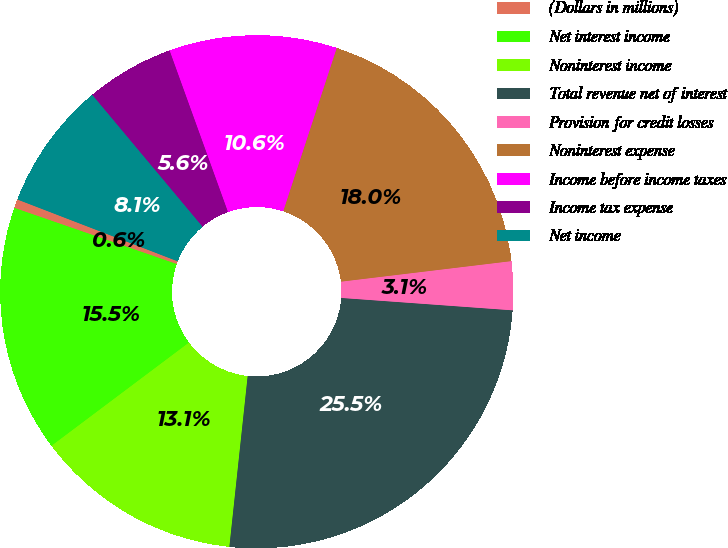Convert chart to OTSL. <chart><loc_0><loc_0><loc_500><loc_500><pie_chart><fcel>(Dollars in millions)<fcel>Net interest income<fcel>Noninterest income<fcel>Total revenue net of interest<fcel>Provision for credit losses<fcel>Noninterest expense<fcel>Income before income taxes<fcel>Income tax expense<fcel>Net income<nl><fcel>0.56%<fcel>15.55%<fcel>13.05%<fcel>25.55%<fcel>3.06%<fcel>18.05%<fcel>10.56%<fcel>5.56%<fcel>8.06%<nl></chart> 